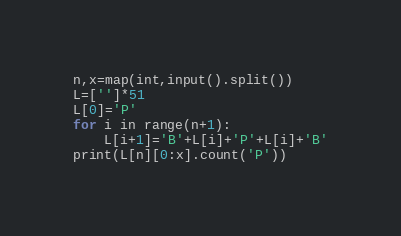<code> <loc_0><loc_0><loc_500><loc_500><_Python_>n,x=map(int,input().split())
L=['']*51
L[0]='P'
for i in range(n+1):
    L[i+1]='B'+L[i]+'P'+L[i]+'B'
print(L[n][0:x].count('P'))</code> 